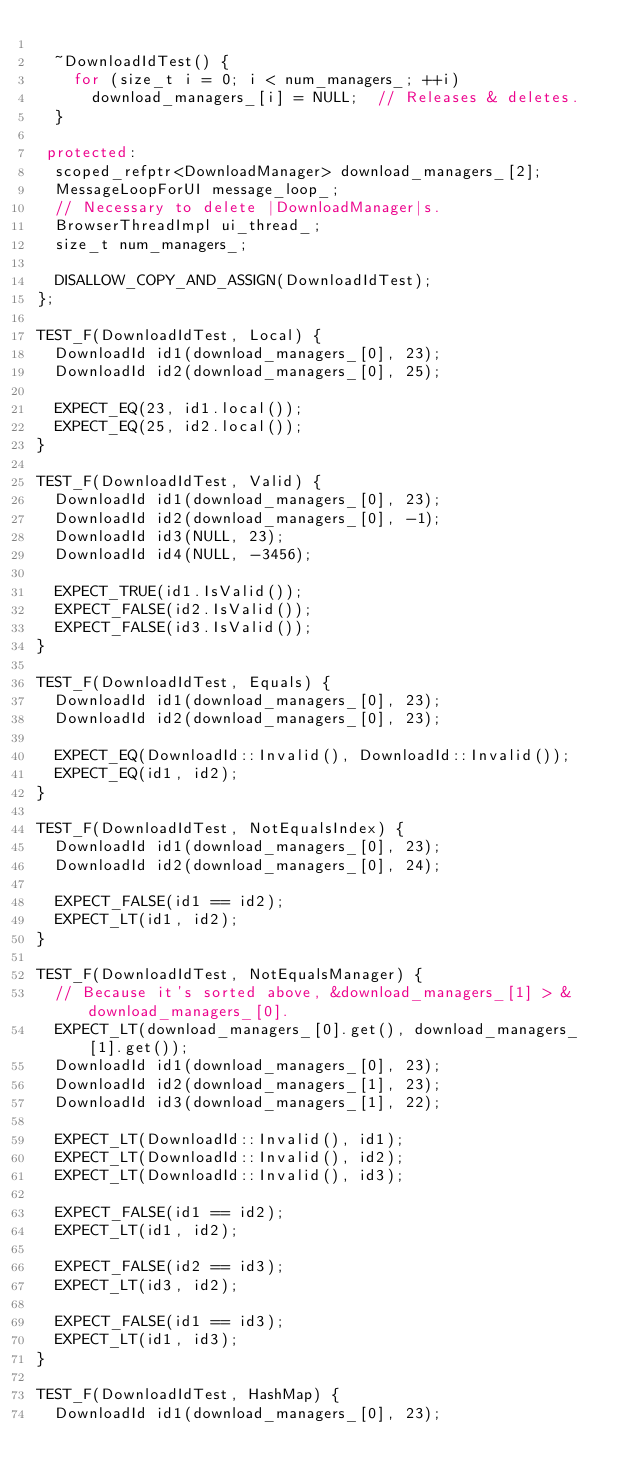<code> <loc_0><loc_0><loc_500><loc_500><_C++_>
  ~DownloadIdTest() {
    for (size_t i = 0; i < num_managers_; ++i)
      download_managers_[i] = NULL;  // Releases & deletes.
  }

 protected:
  scoped_refptr<DownloadManager> download_managers_[2];
  MessageLoopForUI message_loop_;
  // Necessary to delete |DownloadManager|s.
  BrowserThreadImpl ui_thread_;
  size_t num_managers_;

  DISALLOW_COPY_AND_ASSIGN(DownloadIdTest);
};

TEST_F(DownloadIdTest, Local) {
  DownloadId id1(download_managers_[0], 23);
  DownloadId id2(download_managers_[0], 25);

  EXPECT_EQ(23, id1.local());
  EXPECT_EQ(25, id2.local());
}

TEST_F(DownloadIdTest, Valid) {
  DownloadId id1(download_managers_[0], 23);
  DownloadId id2(download_managers_[0], -1);
  DownloadId id3(NULL, 23);
  DownloadId id4(NULL, -3456);

  EXPECT_TRUE(id1.IsValid());
  EXPECT_FALSE(id2.IsValid());
  EXPECT_FALSE(id3.IsValid());
}

TEST_F(DownloadIdTest, Equals) {
  DownloadId id1(download_managers_[0], 23);
  DownloadId id2(download_managers_[0], 23);

  EXPECT_EQ(DownloadId::Invalid(), DownloadId::Invalid());
  EXPECT_EQ(id1, id2);
}

TEST_F(DownloadIdTest, NotEqualsIndex) {
  DownloadId id1(download_managers_[0], 23);
  DownloadId id2(download_managers_[0], 24);

  EXPECT_FALSE(id1 == id2);
  EXPECT_LT(id1, id2);
}

TEST_F(DownloadIdTest, NotEqualsManager) {
  // Because it's sorted above, &download_managers_[1] > &download_managers_[0].
  EXPECT_LT(download_managers_[0].get(), download_managers_[1].get());
  DownloadId id1(download_managers_[0], 23);
  DownloadId id2(download_managers_[1], 23);
  DownloadId id3(download_managers_[1], 22);

  EXPECT_LT(DownloadId::Invalid(), id1);
  EXPECT_LT(DownloadId::Invalid(), id2);
  EXPECT_LT(DownloadId::Invalid(), id3);

  EXPECT_FALSE(id1 == id2);
  EXPECT_LT(id1, id2);

  EXPECT_FALSE(id2 == id3);
  EXPECT_LT(id3, id2);

  EXPECT_FALSE(id1 == id3);
  EXPECT_LT(id1, id3);
}

TEST_F(DownloadIdTest, HashMap) {
  DownloadId id1(download_managers_[0], 23);</code> 